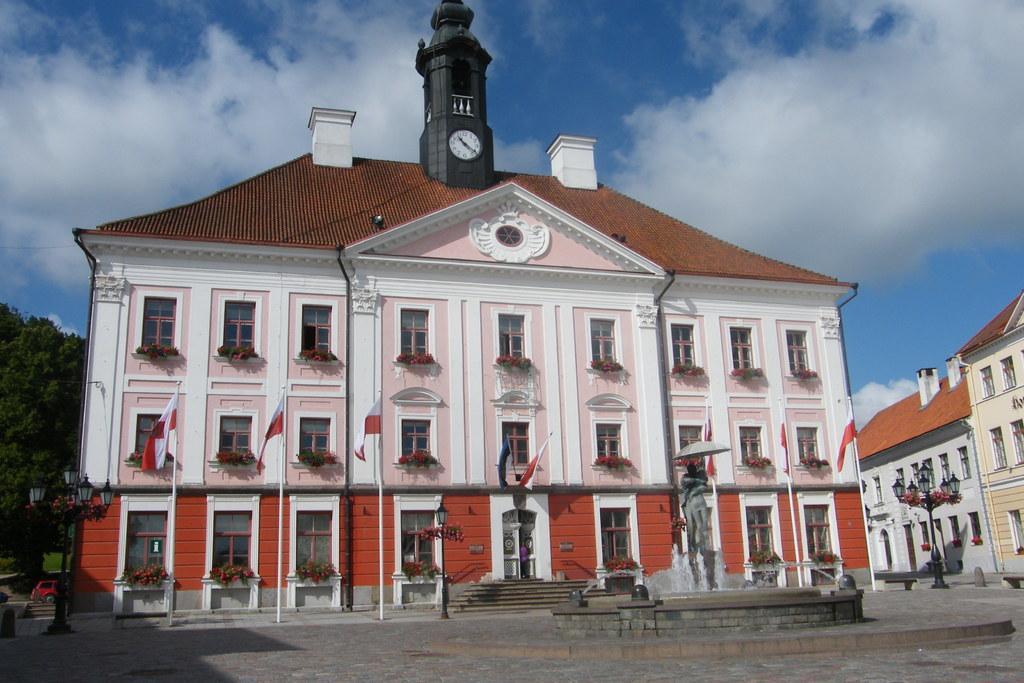Please provide a concise description of this image. In this there are few buildings, in front of it there is a sculpture, water fountain, light poles, at the top there is the sky, on the right side there is a tree. 